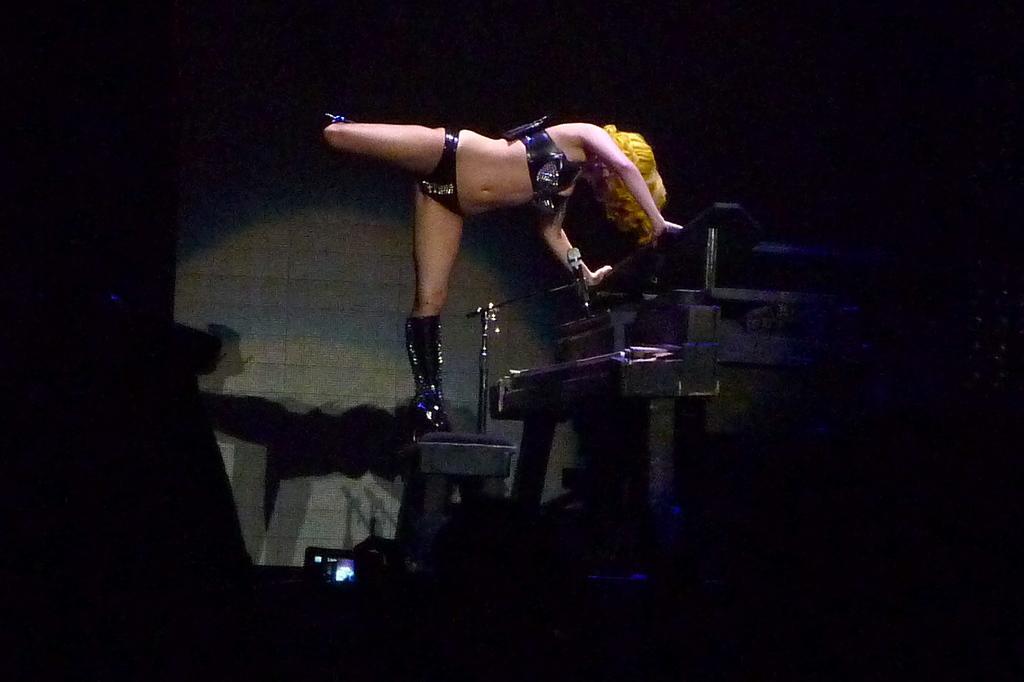How would you summarize this image in a sentence or two? In this image we can see a lady. There are few objects in the image. There is a camera in the image. 